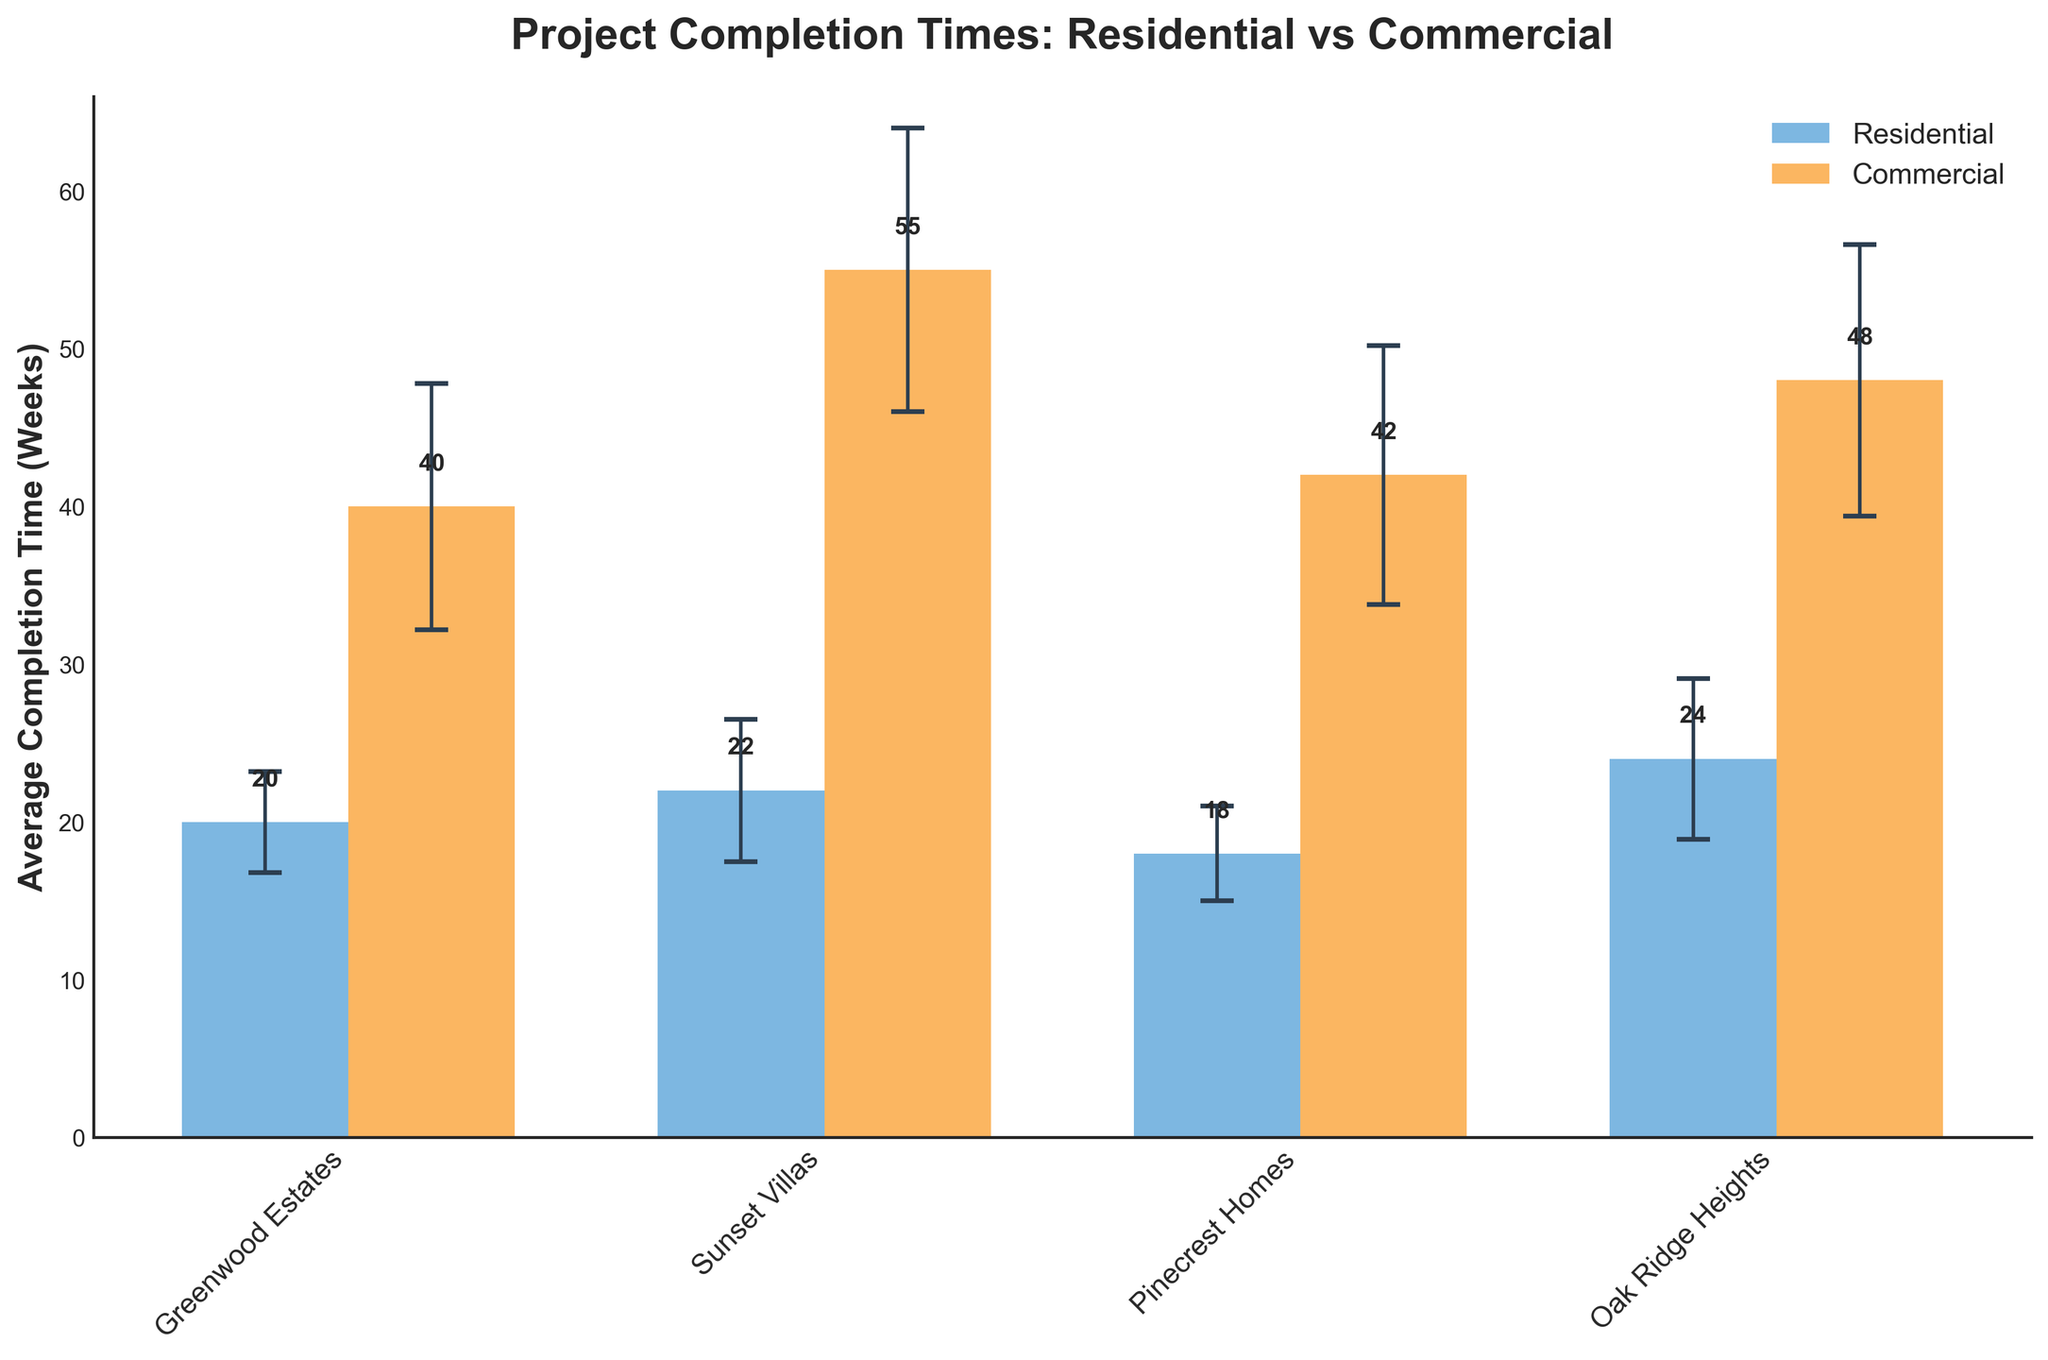What is the title of the graph? The title of the graph is located at the top center of the figure, prominently displayed in a larger and bold font. It should give a clear indication of what the graph is about.
Answer: Project Completion Times: Residential vs Commercial What is the average completion time for the 'Greenwood Estates' project? Look at the bar representing 'Greenwood Estates', then read the average completion time value either from the bar's height or the label above it.
Answer: 20 weeks Which project has the highest average completion time among the Commercial buildings? Identify and compare the heights of all bars labeled under Commercial projects. The tallest bar represents the project with the highest completion time.
Answer: Westgate Mall How does the variance in man-hours for 'Oak Ridge Heights' compare with 'Pinecrest Homes'? Check the error bars for 'Oak Ridge Heights' and 'Pinecrest Homes'. Longer error bars indicate higher variance in man-hours. Compare the lengths visually.
Answer: Oak Ridge Heights has higher variance What's the average completion time difference between 'Riverfront Business Center' and 'TechHub Office Park'? Look at the bar heights for both 'Riverfront Business Center' and 'TechHub Office Park'. Subtract the value of 'TechHub Office Park' from 'Riverfront Business Center' to find the difference.
Answer: 2 weeks What is the color used to represent Commercial building projects? Observe the color of the bars associated with Commercial building projects, as indicated in the legend.
Answer: Orange Which project has the smallest variance in man-hours among the Residential buildings? Compare the lengths of the error bars for all Residential projects. The project with the shortest error bar has the smallest variance.
Answer: Pinecrest Homes For which project do the error bars suggest the widest potential range of completion times? Examine all bars and identify the project with the longest error bars, which imply higher uncertainty in completion time.
Answer: Westgate Mall Are the completion times for Commercial projects consistently higher than Residential projects? Compare the bar heights for all projects under Residential and Commercial categories. Assess if Commercial bars are generally higher than Residential bars.
Answer: Yes, they are consistently higher Which Residential project has the longest average completion time, and how does it compare to the shortest average completion time among Commercial projects? Identify the highest bar under Residential projects and the shortest bar under Commercial projects, then compare their heights.
Answer: Oak Ridge Heights (24 weeks) is shorter than TechHub Office Park (40 weeks) 